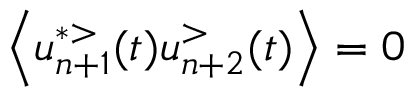<formula> <loc_0><loc_0><loc_500><loc_500>\left \langle u _ { n + 1 } ^ { * > } ( t ) u _ { n + 2 } ^ { > } ( t ) \right \rangle = 0</formula> 